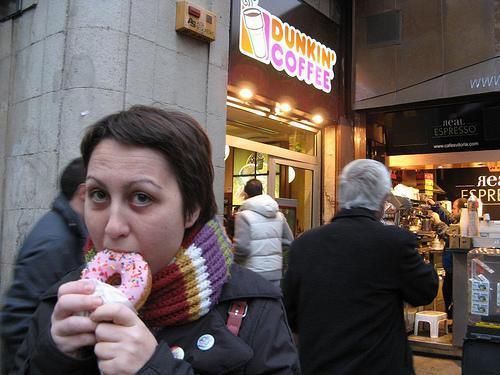How many people can you see?
Give a very brief answer. 4. How many cows are laying down?
Give a very brief answer. 0. 